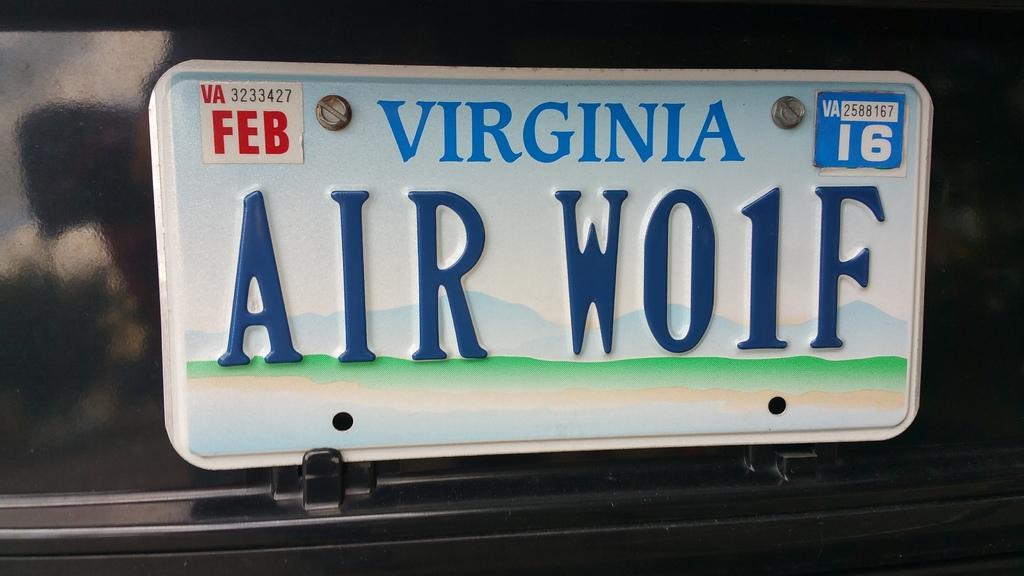Can you describe this image briefly? In the image in the center, we can see one number plate. On the number plate, we can see something written on it. 